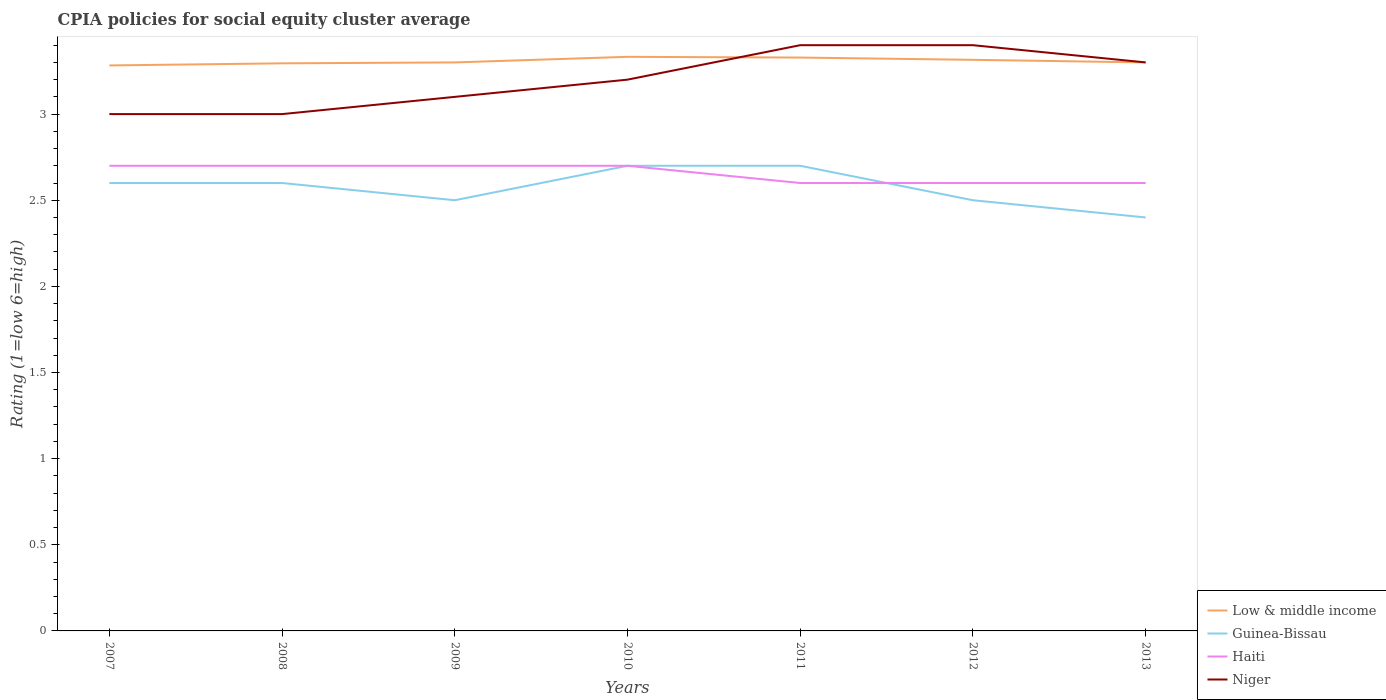How many different coloured lines are there?
Your answer should be compact. 4. Across all years, what is the maximum CPIA rating in Low & middle income?
Make the answer very short. 3.28. In which year was the CPIA rating in Haiti maximum?
Ensure brevity in your answer.  2011. What is the total CPIA rating in Niger in the graph?
Keep it short and to the point. -0.1. What is the difference between the highest and the second highest CPIA rating in Niger?
Offer a very short reply. 0.4. What is the difference between the highest and the lowest CPIA rating in Niger?
Your answer should be very brief. 3. How many lines are there?
Make the answer very short. 4. How many years are there in the graph?
Provide a succinct answer. 7. What is the difference between two consecutive major ticks on the Y-axis?
Provide a succinct answer. 0.5. Does the graph contain any zero values?
Offer a terse response. No. Does the graph contain grids?
Offer a terse response. No. Where does the legend appear in the graph?
Offer a terse response. Bottom right. How are the legend labels stacked?
Offer a terse response. Vertical. What is the title of the graph?
Your answer should be compact. CPIA policies for social equity cluster average. What is the label or title of the X-axis?
Your answer should be very brief. Years. What is the label or title of the Y-axis?
Provide a short and direct response. Rating (1=low 6=high). What is the Rating (1=low 6=high) in Low & middle income in 2007?
Give a very brief answer. 3.28. What is the Rating (1=low 6=high) in Low & middle income in 2008?
Keep it short and to the point. 3.29. What is the Rating (1=low 6=high) in Haiti in 2008?
Give a very brief answer. 2.7. What is the Rating (1=low 6=high) in Niger in 2008?
Ensure brevity in your answer.  3. What is the Rating (1=low 6=high) in Haiti in 2009?
Provide a short and direct response. 2.7. What is the Rating (1=low 6=high) in Low & middle income in 2010?
Offer a terse response. 3.33. What is the Rating (1=low 6=high) in Niger in 2010?
Offer a very short reply. 3.2. What is the Rating (1=low 6=high) in Low & middle income in 2011?
Your answer should be very brief. 3.33. What is the Rating (1=low 6=high) in Haiti in 2011?
Make the answer very short. 2.6. What is the Rating (1=low 6=high) of Niger in 2011?
Offer a very short reply. 3.4. What is the Rating (1=low 6=high) of Low & middle income in 2012?
Keep it short and to the point. 3.31. What is the Rating (1=low 6=high) in Haiti in 2012?
Ensure brevity in your answer.  2.6. What is the Rating (1=low 6=high) in Haiti in 2013?
Offer a very short reply. 2.6. What is the Rating (1=low 6=high) in Niger in 2013?
Provide a succinct answer. 3.3. Across all years, what is the maximum Rating (1=low 6=high) in Low & middle income?
Keep it short and to the point. 3.33. Across all years, what is the maximum Rating (1=low 6=high) in Guinea-Bissau?
Your response must be concise. 2.7. Across all years, what is the maximum Rating (1=low 6=high) in Haiti?
Keep it short and to the point. 2.7. Across all years, what is the minimum Rating (1=low 6=high) of Low & middle income?
Make the answer very short. 3.28. What is the total Rating (1=low 6=high) of Low & middle income in the graph?
Ensure brevity in your answer.  23.15. What is the total Rating (1=low 6=high) of Niger in the graph?
Offer a very short reply. 22.4. What is the difference between the Rating (1=low 6=high) of Low & middle income in 2007 and that in 2008?
Offer a very short reply. -0.01. What is the difference between the Rating (1=low 6=high) of Guinea-Bissau in 2007 and that in 2008?
Keep it short and to the point. 0. What is the difference between the Rating (1=low 6=high) of Haiti in 2007 and that in 2008?
Make the answer very short. 0. What is the difference between the Rating (1=low 6=high) of Low & middle income in 2007 and that in 2009?
Provide a short and direct response. -0.02. What is the difference between the Rating (1=low 6=high) in Guinea-Bissau in 2007 and that in 2009?
Give a very brief answer. 0.1. What is the difference between the Rating (1=low 6=high) in Haiti in 2007 and that in 2009?
Provide a short and direct response. 0. What is the difference between the Rating (1=low 6=high) of Guinea-Bissau in 2007 and that in 2010?
Offer a very short reply. -0.1. What is the difference between the Rating (1=low 6=high) of Niger in 2007 and that in 2010?
Ensure brevity in your answer.  -0.2. What is the difference between the Rating (1=low 6=high) of Low & middle income in 2007 and that in 2011?
Give a very brief answer. -0.05. What is the difference between the Rating (1=low 6=high) of Haiti in 2007 and that in 2011?
Offer a very short reply. 0.1. What is the difference between the Rating (1=low 6=high) in Low & middle income in 2007 and that in 2012?
Offer a terse response. -0.03. What is the difference between the Rating (1=low 6=high) of Guinea-Bissau in 2007 and that in 2012?
Provide a succinct answer. 0.1. What is the difference between the Rating (1=low 6=high) in Low & middle income in 2007 and that in 2013?
Make the answer very short. -0.02. What is the difference between the Rating (1=low 6=high) of Guinea-Bissau in 2007 and that in 2013?
Your response must be concise. 0.2. What is the difference between the Rating (1=low 6=high) in Haiti in 2007 and that in 2013?
Offer a terse response. 0.1. What is the difference between the Rating (1=low 6=high) in Low & middle income in 2008 and that in 2009?
Your response must be concise. -0.01. What is the difference between the Rating (1=low 6=high) of Guinea-Bissau in 2008 and that in 2009?
Keep it short and to the point. 0.1. What is the difference between the Rating (1=low 6=high) of Low & middle income in 2008 and that in 2010?
Provide a short and direct response. -0.04. What is the difference between the Rating (1=low 6=high) of Low & middle income in 2008 and that in 2011?
Your response must be concise. -0.03. What is the difference between the Rating (1=low 6=high) of Low & middle income in 2008 and that in 2012?
Your response must be concise. -0.02. What is the difference between the Rating (1=low 6=high) of Guinea-Bissau in 2008 and that in 2012?
Provide a succinct answer. 0.1. What is the difference between the Rating (1=low 6=high) of Haiti in 2008 and that in 2012?
Make the answer very short. 0.1. What is the difference between the Rating (1=low 6=high) in Low & middle income in 2008 and that in 2013?
Provide a short and direct response. -0.01. What is the difference between the Rating (1=low 6=high) in Low & middle income in 2009 and that in 2010?
Give a very brief answer. -0.03. What is the difference between the Rating (1=low 6=high) in Guinea-Bissau in 2009 and that in 2010?
Your answer should be compact. -0.2. What is the difference between the Rating (1=low 6=high) in Low & middle income in 2009 and that in 2011?
Provide a succinct answer. -0.03. What is the difference between the Rating (1=low 6=high) in Haiti in 2009 and that in 2011?
Your answer should be very brief. 0.1. What is the difference between the Rating (1=low 6=high) in Low & middle income in 2009 and that in 2012?
Offer a terse response. -0.01. What is the difference between the Rating (1=low 6=high) of Haiti in 2009 and that in 2012?
Offer a very short reply. 0.1. What is the difference between the Rating (1=low 6=high) in Niger in 2009 and that in 2012?
Provide a short and direct response. -0.3. What is the difference between the Rating (1=low 6=high) of Guinea-Bissau in 2009 and that in 2013?
Provide a succinct answer. 0.1. What is the difference between the Rating (1=low 6=high) of Low & middle income in 2010 and that in 2011?
Keep it short and to the point. 0. What is the difference between the Rating (1=low 6=high) in Low & middle income in 2010 and that in 2012?
Make the answer very short. 0.02. What is the difference between the Rating (1=low 6=high) of Low & middle income in 2010 and that in 2013?
Keep it short and to the point. 0.03. What is the difference between the Rating (1=low 6=high) of Niger in 2010 and that in 2013?
Provide a short and direct response. -0.1. What is the difference between the Rating (1=low 6=high) in Low & middle income in 2011 and that in 2012?
Provide a succinct answer. 0.01. What is the difference between the Rating (1=low 6=high) in Haiti in 2011 and that in 2012?
Your answer should be compact. 0. What is the difference between the Rating (1=low 6=high) of Niger in 2011 and that in 2012?
Provide a short and direct response. 0. What is the difference between the Rating (1=low 6=high) of Low & middle income in 2011 and that in 2013?
Provide a short and direct response. 0.03. What is the difference between the Rating (1=low 6=high) of Haiti in 2011 and that in 2013?
Provide a succinct answer. 0. What is the difference between the Rating (1=low 6=high) in Low & middle income in 2012 and that in 2013?
Keep it short and to the point. 0.01. What is the difference between the Rating (1=low 6=high) in Guinea-Bissau in 2012 and that in 2013?
Keep it short and to the point. 0.1. What is the difference between the Rating (1=low 6=high) of Haiti in 2012 and that in 2013?
Your answer should be very brief. 0. What is the difference between the Rating (1=low 6=high) in Niger in 2012 and that in 2013?
Your response must be concise. 0.1. What is the difference between the Rating (1=low 6=high) in Low & middle income in 2007 and the Rating (1=low 6=high) in Guinea-Bissau in 2008?
Your answer should be very brief. 0.68. What is the difference between the Rating (1=low 6=high) of Low & middle income in 2007 and the Rating (1=low 6=high) of Haiti in 2008?
Your answer should be very brief. 0.58. What is the difference between the Rating (1=low 6=high) in Low & middle income in 2007 and the Rating (1=low 6=high) in Niger in 2008?
Offer a terse response. 0.28. What is the difference between the Rating (1=low 6=high) of Guinea-Bissau in 2007 and the Rating (1=low 6=high) of Haiti in 2008?
Keep it short and to the point. -0.1. What is the difference between the Rating (1=low 6=high) in Haiti in 2007 and the Rating (1=low 6=high) in Niger in 2008?
Make the answer very short. -0.3. What is the difference between the Rating (1=low 6=high) of Low & middle income in 2007 and the Rating (1=low 6=high) of Guinea-Bissau in 2009?
Your response must be concise. 0.78. What is the difference between the Rating (1=low 6=high) of Low & middle income in 2007 and the Rating (1=low 6=high) of Haiti in 2009?
Keep it short and to the point. 0.58. What is the difference between the Rating (1=low 6=high) in Low & middle income in 2007 and the Rating (1=low 6=high) in Niger in 2009?
Give a very brief answer. 0.18. What is the difference between the Rating (1=low 6=high) in Guinea-Bissau in 2007 and the Rating (1=low 6=high) in Niger in 2009?
Your answer should be very brief. -0.5. What is the difference between the Rating (1=low 6=high) of Haiti in 2007 and the Rating (1=low 6=high) of Niger in 2009?
Provide a short and direct response. -0.4. What is the difference between the Rating (1=low 6=high) of Low & middle income in 2007 and the Rating (1=low 6=high) of Guinea-Bissau in 2010?
Ensure brevity in your answer.  0.58. What is the difference between the Rating (1=low 6=high) in Low & middle income in 2007 and the Rating (1=low 6=high) in Haiti in 2010?
Your answer should be compact. 0.58. What is the difference between the Rating (1=low 6=high) of Low & middle income in 2007 and the Rating (1=low 6=high) of Niger in 2010?
Provide a short and direct response. 0.08. What is the difference between the Rating (1=low 6=high) in Haiti in 2007 and the Rating (1=low 6=high) in Niger in 2010?
Your response must be concise. -0.5. What is the difference between the Rating (1=low 6=high) in Low & middle income in 2007 and the Rating (1=low 6=high) in Guinea-Bissau in 2011?
Give a very brief answer. 0.58. What is the difference between the Rating (1=low 6=high) in Low & middle income in 2007 and the Rating (1=low 6=high) in Haiti in 2011?
Offer a very short reply. 0.68. What is the difference between the Rating (1=low 6=high) in Low & middle income in 2007 and the Rating (1=low 6=high) in Niger in 2011?
Make the answer very short. -0.12. What is the difference between the Rating (1=low 6=high) in Guinea-Bissau in 2007 and the Rating (1=low 6=high) in Haiti in 2011?
Give a very brief answer. 0. What is the difference between the Rating (1=low 6=high) of Guinea-Bissau in 2007 and the Rating (1=low 6=high) of Niger in 2011?
Your answer should be very brief. -0.8. What is the difference between the Rating (1=low 6=high) in Low & middle income in 2007 and the Rating (1=low 6=high) in Guinea-Bissau in 2012?
Make the answer very short. 0.78. What is the difference between the Rating (1=low 6=high) in Low & middle income in 2007 and the Rating (1=low 6=high) in Haiti in 2012?
Your answer should be very brief. 0.68. What is the difference between the Rating (1=low 6=high) in Low & middle income in 2007 and the Rating (1=low 6=high) in Niger in 2012?
Ensure brevity in your answer.  -0.12. What is the difference between the Rating (1=low 6=high) of Guinea-Bissau in 2007 and the Rating (1=low 6=high) of Haiti in 2012?
Make the answer very short. 0. What is the difference between the Rating (1=low 6=high) in Guinea-Bissau in 2007 and the Rating (1=low 6=high) in Niger in 2012?
Offer a very short reply. -0.8. What is the difference between the Rating (1=low 6=high) of Haiti in 2007 and the Rating (1=low 6=high) of Niger in 2012?
Offer a very short reply. -0.7. What is the difference between the Rating (1=low 6=high) in Low & middle income in 2007 and the Rating (1=low 6=high) in Guinea-Bissau in 2013?
Provide a succinct answer. 0.88. What is the difference between the Rating (1=low 6=high) in Low & middle income in 2007 and the Rating (1=low 6=high) in Haiti in 2013?
Your answer should be compact. 0.68. What is the difference between the Rating (1=low 6=high) in Low & middle income in 2007 and the Rating (1=low 6=high) in Niger in 2013?
Provide a succinct answer. -0.02. What is the difference between the Rating (1=low 6=high) of Guinea-Bissau in 2007 and the Rating (1=low 6=high) of Niger in 2013?
Your answer should be very brief. -0.7. What is the difference between the Rating (1=low 6=high) in Low & middle income in 2008 and the Rating (1=low 6=high) in Guinea-Bissau in 2009?
Ensure brevity in your answer.  0.79. What is the difference between the Rating (1=low 6=high) of Low & middle income in 2008 and the Rating (1=low 6=high) of Haiti in 2009?
Make the answer very short. 0.59. What is the difference between the Rating (1=low 6=high) of Low & middle income in 2008 and the Rating (1=low 6=high) of Niger in 2009?
Offer a terse response. 0.19. What is the difference between the Rating (1=low 6=high) of Low & middle income in 2008 and the Rating (1=low 6=high) of Guinea-Bissau in 2010?
Your answer should be compact. 0.59. What is the difference between the Rating (1=low 6=high) of Low & middle income in 2008 and the Rating (1=low 6=high) of Haiti in 2010?
Make the answer very short. 0.59. What is the difference between the Rating (1=low 6=high) of Low & middle income in 2008 and the Rating (1=low 6=high) of Niger in 2010?
Your answer should be compact. 0.09. What is the difference between the Rating (1=low 6=high) of Guinea-Bissau in 2008 and the Rating (1=low 6=high) of Haiti in 2010?
Offer a terse response. -0.1. What is the difference between the Rating (1=low 6=high) in Guinea-Bissau in 2008 and the Rating (1=low 6=high) in Niger in 2010?
Keep it short and to the point. -0.6. What is the difference between the Rating (1=low 6=high) in Haiti in 2008 and the Rating (1=low 6=high) in Niger in 2010?
Ensure brevity in your answer.  -0.5. What is the difference between the Rating (1=low 6=high) of Low & middle income in 2008 and the Rating (1=low 6=high) of Guinea-Bissau in 2011?
Ensure brevity in your answer.  0.59. What is the difference between the Rating (1=low 6=high) in Low & middle income in 2008 and the Rating (1=low 6=high) in Haiti in 2011?
Keep it short and to the point. 0.69. What is the difference between the Rating (1=low 6=high) in Low & middle income in 2008 and the Rating (1=low 6=high) in Niger in 2011?
Offer a terse response. -0.11. What is the difference between the Rating (1=low 6=high) of Guinea-Bissau in 2008 and the Rating (1=low 6=high) of Haiti in 2011?
Provide a short and direct response. 0. What is the difference between the Rating (1=low 6=high) in Guinea-Bissau in 2008 and the Rating (1=low 6=high) in Niger in 2011?
Make the answer very short. -0.8. What is the difference between the Rating (1=low 6=high) of Low & middle income in 2008 and the Rating (1=low 6=high) of Guinea-Bissau in 2012?
Offer a terse response. 0.79. What is the difference between the Rating (1=low 6=high) in Low & middle income in 2008 and the Rating (1=low 6=high) in Haiti in 2012?
Give a very brief answer. 0.69. What is the difference between the Rating (1=low 6=high) of Low & middle income in 2008 and the Rating (1=low 6=high) of Niger in 2012?
Your answer should be compact. -0.11. What is the difference between the Rating (1=low 6=high) in Haiti in 2008 and the Rating (1=low 6=high) in Niger in 2012?
Your answer should be compact. -0.7. What is the difference between the Rating (1=low 6=high) of Low & middle income in 2008 and the Rating (1=low 6=high) of Guinea-Bissau in 2013?
Offer a terse response. 0.89. What is the difference between the Rating (1=low 6=high) of Low & middle income in 2008 and the Rating (1=low 6=high) of Haiti in 2013?
Your answer should be very brief. 0.69. What is the difference between the Rating (1=low 6=high) of Low & middle income in 2008 and the Rating (1=low 6=high) of Niger in 2013?
Make the answer very short. -0.01. What is the difference between the Rating (1=low 6=high) in Guinea-Bissau in 2008 and the Rating (1=low 6=high) in Haiti in 2013?
Provide a short and direct response. 0. What is the difference between the Rating (1=low 6=high) in Guinea-Bissau in 2008 and the Rating (1=low 6=high) in Niger in 2013?
Offer a terse response. -0.7. What is the difference between the Rating (1=low 6=high) of Low & middle income in 2009 and the Rating (1=low 6=high) of Guinea-Bissau in 2010?
Give a very brief answer. 0.6. What is the difference between the Rating (1=low 6=high) in Low & middle income in 2009 and the Rating (1=low 6=high) in Haiti in 2010?
Offer a terse response. 0.6. What is the difference between the Rating (1=low 6=high) of Low & middle income in 2009 and the Rating (1=low 6=high) of Niger in 2010?
Your answer should be compact. 0.1. What is the difference between the Rating (1=low 6=high) in Guinea-Bissau in 2009 and the Rating (1=low 6=high) in Haiti in 2010?
Your answer should be compact. -0.2. What is the difference between the Rating (1=low 6=high) of Haiti in 2009 and the Rating (1=low 6=high) of Niger in 2010?
Make the answer very short. -0.5. What is the difference between the Rating (1=low 6=high) in Low & middle income in 2009 and the Rating (1=low 6=high) in Haiti in 2011?
Provide a succinct answer. 0.7. What is the difference between the Rating (1=low 6=high) of Guinea-Bissau in 2009 and the Rating (1=low 6=high) of Haiti in 2011?
Your answer should be very brief. -0.1. What is the difference between the Rating (1=low 6=high) of Guinea-Bissau in 2009 and the Rating (1=low 6=high) of Niger in 2012?
Your answer should be compact. -0.9. What is the difference between the Rating (1=low 6=high) of Haiti in 2009 and the Rating (1=low 6=high) of Niger in 2012?
Your response must be concise. -0.7. What is the difference between the Rating (1=low 6=high) of Low & middle income in 2009 and the Rating (1=low 6=high) of Haiti in 2013?
Give a very brief answer. 0.7. What is the difference between the Rating (1=low 6=high) of Low & middle income in 2009 and the Rating (1=low 6=high) of Niger in 2013?
Keep it short and to the point. 0. What is the difference between the Rating (1=low 6=high) of Guinea-Bissau in 2009 and the Rating (1=low 6=high) of Haiti in 2013?
Make the answer very short. -0.1. What is the difference between the Rating (1=low 6=high) in Guinea-Bissau in 2009 and the Rating (1=low 6=high) in Niger in 2013?
Make the answer very short. -0.8. What is the difference between the Rating (1=low 6=high) in Haiti in 2009 and the Rating (1=low 6=high) in Niger in 2013?
Give a very brief answer. -0.6. What is the difference between the Rating (1=low 6=high) of Low & middle income in 2010 and the Rating (1=low 6=high) of Guinea-Bissau in 2011?
Provide a succinct answer. 0.63. What is the difference between the Rating (1=low 6=high) of Low & middle income in 2010 and the Rating (1=low 6=high) of Haiti in 2011?
Provide a short and direct response. 0.73. What is the difference between the Rating (1=low 6=high) in Low & middle income in 2010 and the Rating (1=low 6=high) in Niger in 2011?
Offer a very short reply. -0.07. What is the difference between the Rating (1=low 6=high) in Low & middle income in 2010 and the Rating (1=low 6=high) in Guinea-Bissau in 2012?
Keep it short and to the point. 0.83. What is the difference between the Rating (1=low 6=high) in Low & middle income in 2010 and the Rating (1=low 6=high) in Haiti in 2012?
Keep it short and to the point. 0.73. What is the difference between the Rating (1=low 6=high) in Low & middle income in 2010 and the Rating (1=low 6=high) in Niger in 2012?
Give a very brief answer. -0.07. What is the difference between the Rating (1=low 6=high) in Guinea-Bissau in 2010 and the Rating (1=low 6=high) in Haiti in 2012?
Provide a short and direct response. 0.1. What is the difference between the Rating (1=low 6=high) in Guinea-Bissau in 2010 and the Rating (1=low 6=high) in Niger in 2012?
Your answer should be very brief. -0.7. What is the difference between the Rating (1=low 6=high) in Low & middle income in 2010 and the Rating (1=low 6=high) in Guinea-Bissau in 2013?
Keep it short and to the point. 0.93. What is the difference between the Rating (1=low 6=high) of Low & middle income in 2010 and the Rating (1=low 6=high) of Haiti in 2013?
Offer a terse response. 0.73. What is the difference between the Rating (1=low 6=high) in Low & middle income in 2010 and the Rating (1=low 6=high) in Niger in 2013?
Keep it short and to the point. 0.03. What is the difference between the Rating (1=low 6=high) of Guinea-Bissau in 2010 and the Rating (1=low 6=high) of Haiti in 2013?
Give a very brief answer. 0.1. What is the difference between the Rating (1=low 6=high) of Guinea-Bissau in 2010 and the Rating (1=low 6=high) of Niger in 2013?
Offer a very short reply. -0.6. What is the difference between the Rating (1=low 6=high) in Low & middle income in 2011 and the Rating (1=low 6=high) in Guinea-Bissau in 2012?
Provide a succinct answer. 0.83. What is the difference between the Rating (1=low 6=high) of Low & middle income in 2011 and the Rating (1=low 6=high) of Haiti in 2012?
Offer a terse response. 0.73. What is the difference between the Rating (1=low 6=high) of Low & middle income in 2011 and the Rating (1=low 6=high) of Niger in 2012?
Your response must be concise. -0.07. What is the difference between the Rating (1=low 6=high) of Guinea-Bissau in 2011 and the Rating (1=low 6=high) of Haiti in 2012?
Your response must be concise. 0.1. What is the difference between the Rating (1=low 6=high) in Haiti in 2011 and the Rating (1=low 6=high) in Niger in 2012?
Your response must be concise. -0.8. What is the difference between the Rating (1=low 6=high) in Low & middle income in 2011 and the Rating (1=low 6=high) in Guinea-Bissau in 2013?
Ensure brevity in your answer.  0.93. What is the difference between the Rating (1=low 6=high) in Low & middle income in 2011 and the Rating (1=low 6=high) in Haiti in 2013?
Offer a terse response. 0.73. What is the difference between the Rating (1=low 6=high) of Low & middle income in 2011 and the Rating (1=low 6=high) of Niger in 2013?
Make the answer very short. 0.03. What is the difference between the Rating (1=low 6=high) of Guinea-Bissau in 2011 and the Rating (1=low 6=high) of Haiti in 2013?
Offer a terse response. 0.1. What is the difference between the Rating (1=low 6=high) in Low & middle income in 2012 and the Rating (1=low 6=high) in Guinea-Bissau in 2013?
Your answer should be very brief. 0.92. What is the difference between the Rating (1=low 6=high) of Low & middle income in 2012 and the Rating (1=low 6=high) of Haiti in 2013?
Offer a terse response. 0.71. What is the difference between the Rating (1=low 6=high) of Low & middle income in 2012 and the Rating (1=low 6=high) of Niger in 2013?
Offer a terse response. 0.01. What is the difference between the Rating (1=low 6=high) in Guinea-Bissau in 2012 and the Rating (1=low 6=high) in Niger in 2013?
Provide a succinct answer. -0.8. What is the difference between the Rating (1=low 6=high) of Haiti in 2012 and the Rating (1=low 6=high) of Niger in 2013?
Ensure brevity in your answer.  -0.7. What is the average Rating (1=low 6=high) in Low & middle income per year?
Offer a very short reply. 3.31. What is the average Rating (1=low 6=high) in Guinea-Bissau per year?
Give a very brief answer. 2.57. What is the average Rating (1=low 6=high) in Haiti per year?
Offer a terse response. 2.66. What is the average Rating (1=low 6=high) of Niger per year?
Offer a terse response. 3.2. In the year 2007, what is the difference between the Rating (1=low 6=high) of Low & middle income and Rating (1=low 6=high) of Guinea-Bissau?
Your answer should be compact. 0.68. In the year 2007, what is the difference between the Rating (1=low 6=high) in Low & middle income and Rating (1=low 6=high) in Haiti?
Your answer should be compact. 0.58. In the year 2007, what is the difference between the Rating (1=low 6=high) in Low & middle income and Rating (1=low 6=high) in Niger?
Offer a terse response. 0.28. In the year 2007, what is the difference between the Rating (1=low 6=high) in Guinea-Bissau and Rating (1=low 6=high) in Niger?
Your answer should be very brief. -0.4. In the year 2007, what is the difference between the Rating (1=low 6=high) of Haiti and Rating (1=low 6=high) of Niger?
Offer a very short reply. -0.3. In the year 2008, what is the difference between the Rating (1=low 6=high) of Low & middle income and Rating (1=low 6=high) of Guinea-Bissau?
Your answer should be compact. 0.69. In the year 2008, what is the difference between the Rating (1=low 6=high) of Low & middle income and Rating (1=low 6=high) of Haiti?
Your answer should be compact. 0.59. In the year 2008, what is the difference between the Rating (1=low 6=high) of Low & middle income and Rating (1=low 6=high) of Niger?
Ensure brevity in your answer.  0.29. In the year 2008, what is the difference between the Rating (1=low 6=high) of Haiti and Rating (1=low 6=high) of Niger?
Offer a terse response. -0.3. In the year 2009, what is the difference between the Rating (1=low 6=high) of Low & middle income and Rating (1=low 6=high) of Haiti?
Offer a terse response. 0.6. In the year 2009, what is the difference between the Rating (1=low 6=high) of Low & middle income and Rating (1=low 6=high) of Niger?
Provide a short and direct response. 0.2. In the year 2010, what is the difference between the Rating (1=low 6=high) in Low & middle income and Rating (1=low 6=high) in Guinea-Bissau?
Offer a very short reply. 0.63. In the year 2010, what is the difference between the Rating (1=low 6=high) of Low & middle income and Rating (1=low 6=high) of Haiti?
Your response must be concise. 0.63. In the year 2010, what is the difference between the Rating (1=low 6=high) in Low & middle income and Rating (1=low 6=high) in Niger?
Offer a very short reply. 0.13. In the year 2010, what is the difference between the Rating (1=low 6=high) in Guinea-Bissau and Rating (1=low 6=high) in Haiti?
Provide a short and direct response. 0. In the year 2011, what is the difference between the Rating (1=low 6=high) in Low & middle income and Rating (1=low 6=high) in Guinea-Bissau?
Ensure brevity in your answer.  0.63. In the year 2011, what is the difference between the Rating (1=low 6=high) of Low & middle income and Rating (1=low 6=high) of Haiti?
Provide a short and direct response. 0.73. In the year 2011, what is the difference between the Rating (1=low 6=high) of Low & middle income and Rating (1=low 6=high) of Niger?
Your response must be concise. -0.07. In the year 2011, what is the difference between the Rating (1=low 6=high) of Guinea-Bissau and Rating (1=low 6=high) of Niger?
Provide a succinct answer. -0.7. In the year 2012, what is the difference between the Rating (1=low 6=high) in Low & middle income and Rating (1=low 6=high) in Guinea-Bissau?
Keep it short and to the point. 0.81. In the year 2012, what is the difference between the Rating (1=low 6=high) in Low & middle income and Rating (1=low 6=high) in Haiti?
Your response must be concise. 0.71. In the year 2012, what is the difference between the Rating (1=low 6=high) of Low & middle income and Rating (1=low 6=high) of Niger?
Keep it short and to the point. -0.09. In the year 2012, what is the difference between the Rating (1=low 6=high) of Guinea-Bissau and Rating (1=low 6=high) of Haiti?
Offer a very short reply. -0.1. In the year 2012, what is the difference between the Rating (1=low 6=high) in Haiti and Rating (1=low 6=high) in Niger?
Offer a very short reply. -0.8. In the year 2013, what is the difference between the Rating (1=low 6=high) in Low & middle income and Rating (1=low 6=high) in Haiti?
Offer a very short reply. 0.7. In the year 2013, what is the difference between the Rating (1=low 6=high) of Guinea-Bissau and Rating (1=low 6=high) of Haiti?
Your answer should be compact. -0.2. What is the ratio of the Rating (1=low 6=high) of Guinea-Bissau in 2007 to that in 2008?
Keep it short and to the point. 1. What is the ratio of the Rating (1=low 6=high) in Guinea-Bissau in 2007 to that in 2010?
Give a very brief answer. 0.96. What is the ratio of the Rating (1=low 6=high) of Haiti in 2007 to that in 2010?
Ensure brevity in your answer.  1. What is the ratio of the Rating (1=low 6=high) of Low & middle income in 2007 to that in 2011?
Your answer should be very brief. 0.99. What is the ratio of the Rating (1=low 6=high) of Niger in 2007 to that in 2011?
Offer a terse response. 0.88. What is the ratio of the Rating (1=low 6=high) in Low & middle income in 2007 to that in 2012?
Ensure brevity in your answer.  0.99. What is the ratio of the Rating (1=low 6=high) of Guinea-Bissau in 2007 to that in 2012?
Keep it short and to the point. 1.04. What is the ratio of the Rating (1=low 6=high) of Haiti in 2007 to that in 2012?
Provide a succinct answer. 1.04. What is the ratio of the Rating (1=low 6=high) in Niger in 2007 to that in 2012?
Make the answer very short. 0.88. What is the ratio of the Rating (1=low 6=high) of Low & middle income in 2008 to that in 2009?
Give a very brief answer. 1. What is the ratio of the Rating (1=low 6=high) of Guinea-Bissau in 2008 to that in 2009?
Your response must be concise. 1.04. What is the ratio of the Rating (1=low 6=high) of Niger in 2008 to that in 2009?
Make the answer very short. 0.97. What is the ratio of the Rating (1=low 6=high) of Low & middle income in 2008 to that in 2010?
Offer a very short reply. 0.99. What is the ratio of the Rating (1=low 6=high) of Guinea-Bissau in 2008 to that in 2010?
Keep it short and to the point. 0.96. What is the ratio of the Rating (1=low 6=high) in Niger in 2008 to that in 2011?
Offer a very short reply. 0.88. What is the ratio of the Rating (1=low 6=high) in Low & middle income in 2008 to that in 2012?
Ensure brevity in your answer.  0.99. What is the ratio of the Rating (1=low 6=high) in Guinea-Bissau in 2008 to that in 2012?
Your response must be concise. 1.04. What is the ratio of the Rating (1=low 6=high) in Haiti in 2008 to that in 2012?
Ensure brevity in your answer.  1.04. What is the ratio of the Rating (1=low 6=high) of Niger in 2008 to that in 2012?
Keep it short and to the point. 0.88. What is the ratio of the Rating (1=low 6=high) in Guinea-Bissau in 2008 to that in 2013?
Make the answer very short. 1.08. What is the ratio of the Rating (1=low 6=high) of Haiti in 2008 to that in 2013?
Provide a succinct answer. 1.04. What is the ratio of the Rating (1=low 6=high) in Low & middle income in 2009 to that in 2010?
Give a very brief answer. 0.99. What is the ratio of the Rating (1=low 6=high) in Guinea-Bissau in 2009 to that in 2010?
Offer a terse response. 0.93. What is the ratio of the Rating (1=low 6=high) of Niger in 2009 to that in 2010?
Make the answer very short. 0.97. What is the ratio of the Rating (1=low 6=high) of Low & middle income in 2009 to that in 2011?
Offer a very short reply. 0.99. What is the ratio of the Rating (1=low 6=high) of Guinea-Bissau in 2009 to that in 2011?
Offer a terse response. 0.93. What is the ratio of the Rating (1=low 6=high) of Niger in 2009 to that in 2011?
Offer a terse response. 0.91. What is the ratio of the Rating (1=low 6=high) of Guinea-Bissau in 2009 to that in 2012?
Provide a succinct answer. 1. What is the ratio of the Rating (1=low 6=high) in Niger in 2009 to that in 2012?
Offer a very short reply. 0.91. What is the ratio of the Rating (1=low 6=high) in Low & middle income in 2009 to that in 2013?
Provide a short and direct response. 1. What is the ratio of the Rating (1=low 6=high) in Guinea-Bissau in 2009 to that in 2013?
Keep it short and to the point. 1.04. What is the ratio of the Rating (1=low 6=high) in Niger in 2009 to that in 2013?
Give a very brief answer. 0.94. What is the ratio of the Rating (1=low 6=high) in Guinea-Bissau in 2010 to that in 2011?
Give a very brief answer. 1. What is the ratio of the Rating (1=low 6=high) in Haiti in 2010 to that in 2011?
Ensure brevity in your answer.  1.04. What is the ratio of the Rating (1=low 6=high) in Niger in 2010 to that in 2011?
Offer a terse response. 0.94. What is the ratio of the Rating (1=low 6=high) in Guinea-Bissau in 2010 to that in 2012?
Offer a very short reply. 1.08. What is the ratio of the Rating (1=low 6=high) of Haiti in 2010 to that in 2012?
Give a very brief answer. 1.04. What is the ratio of the Rating (1=low 6=high) of Niger in 2010 to that in 2012?
Offer a very short reply. 0.94. What is the ratio of the Rating (1=low 6=high) in Low & middle income in 2010 to that in 2013?
Ensure brevity in your answer.  1.01. What is the ratio of the Rating (1=low 6=high) of Guinea-Bissau in 2010 to that in 2013?
Offer a very short reply. 1.12. What is the ratio of the Rating (1=low 6=high) of Niger in 2010 to that in 2013?
Make the answer very short. 0.97. What is the ratio of the Rating (1=low 6=high) in Guinea-Bissau in 2011 to that in 2012?
Your answer should be compact. 1.08. What is the ratio of the Rating (1=low 6=high) in Low & middle income in 2011 to that in 2013?
Give a very brief answer. 1.01. What is the ratio of the Rating (1=low 6=high) in Guinea-Bissau in 2011 to that in 2013?
Provide a succinct answer. 1.12. What is the ratio of the Rating (1=low 6=high) in Haiti in 2011 to that in 2013?
Your response must be concise. 1. What is the ratio of the Rating (1=low 6=high) of Niger in 2011 to that in 2013?
Ensure brevity in your answer.  1.03. What is the ratio of the Rating (1=low 6=high) in Low & middle income in 2012 to that in 2013?
Your response must be concise. 1. What is the ratio of the Rating (1=low 6=high) in Guinea-Bissau in 2012 to that in 2013?
Offer a very short reply. 1.04. What is the ratio of the Rating (1=low 6=high) in Haiti in 2012 to that in 2013?
Your response must be concise. 1. What is the ratio of the Rating (1=low 6=high) of Niger in 2012 to that in 2013?
Offer a very short reply. 1.03. What is the difference between the highest and the second highest Rating (1=low 6=high) of Low & middle income?
Offer a very short reply. 0. What is the difference between the highest and the lowest Rating (1=low 6=high) of Guinea-Bissau?
Your answer should be compact. 0.3. What is the difference between the highest and the lowest Rating (1=low 6=high) in Haiti?
Provide a succinct answer. 0.1. What is the difference between the highest and the lowest Rating (1=low 6=high) in Niger?
Provide a succinct answer. 0.4. 